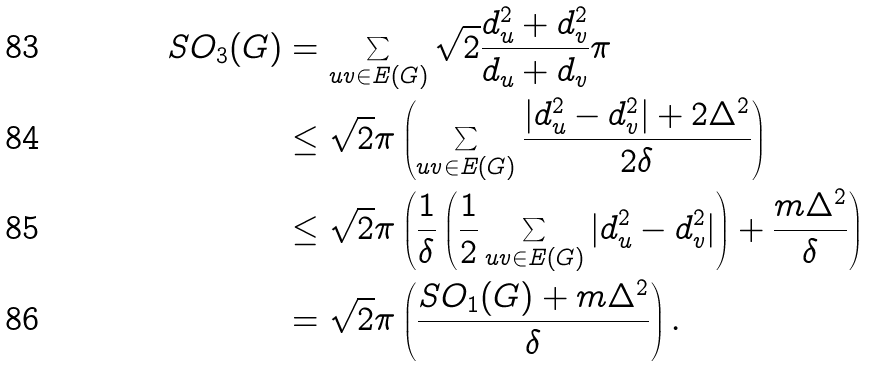<formula> <loc_0><loc_0><loc_500><loc_500>S O _ { 3 } ( G ) & = \sum _ { u v \in E ( G ) } \sqrt { 2 } \frac { d _ { u } ^ { 2 } + d _ { v } ^ { 2 } } { d _ { u } + d _ { v } } \pi \\ & \leq \sqrt { 2 } \pi \left ( \sum _ { u v \in E ( G ) } \frac { | d _ { u } ^ { 2 } - d _ { v } ^ { 2 } | + 2 \Delta ^ { 2 } } { 2 \delta } \right ) \\ & \leq \sqrt { 2 } \pi \left ( \frac { 1 } { \delta } \left ( \frac { 1 } { 2 } \sum _ { u v \in E ( G ) } | d _ { u } ^ { 2 } - d _ { v } ^ { 2 } | \right ) + \frac { m \Delta ^ { 2 } } { \delta } \right ) \\ & = \sqrt { 2 } \pi \left ( \frac { S O _ { 1 } ( G ) + m \Delta ^ { 2 } } { \delta } \right ) .</formula> 